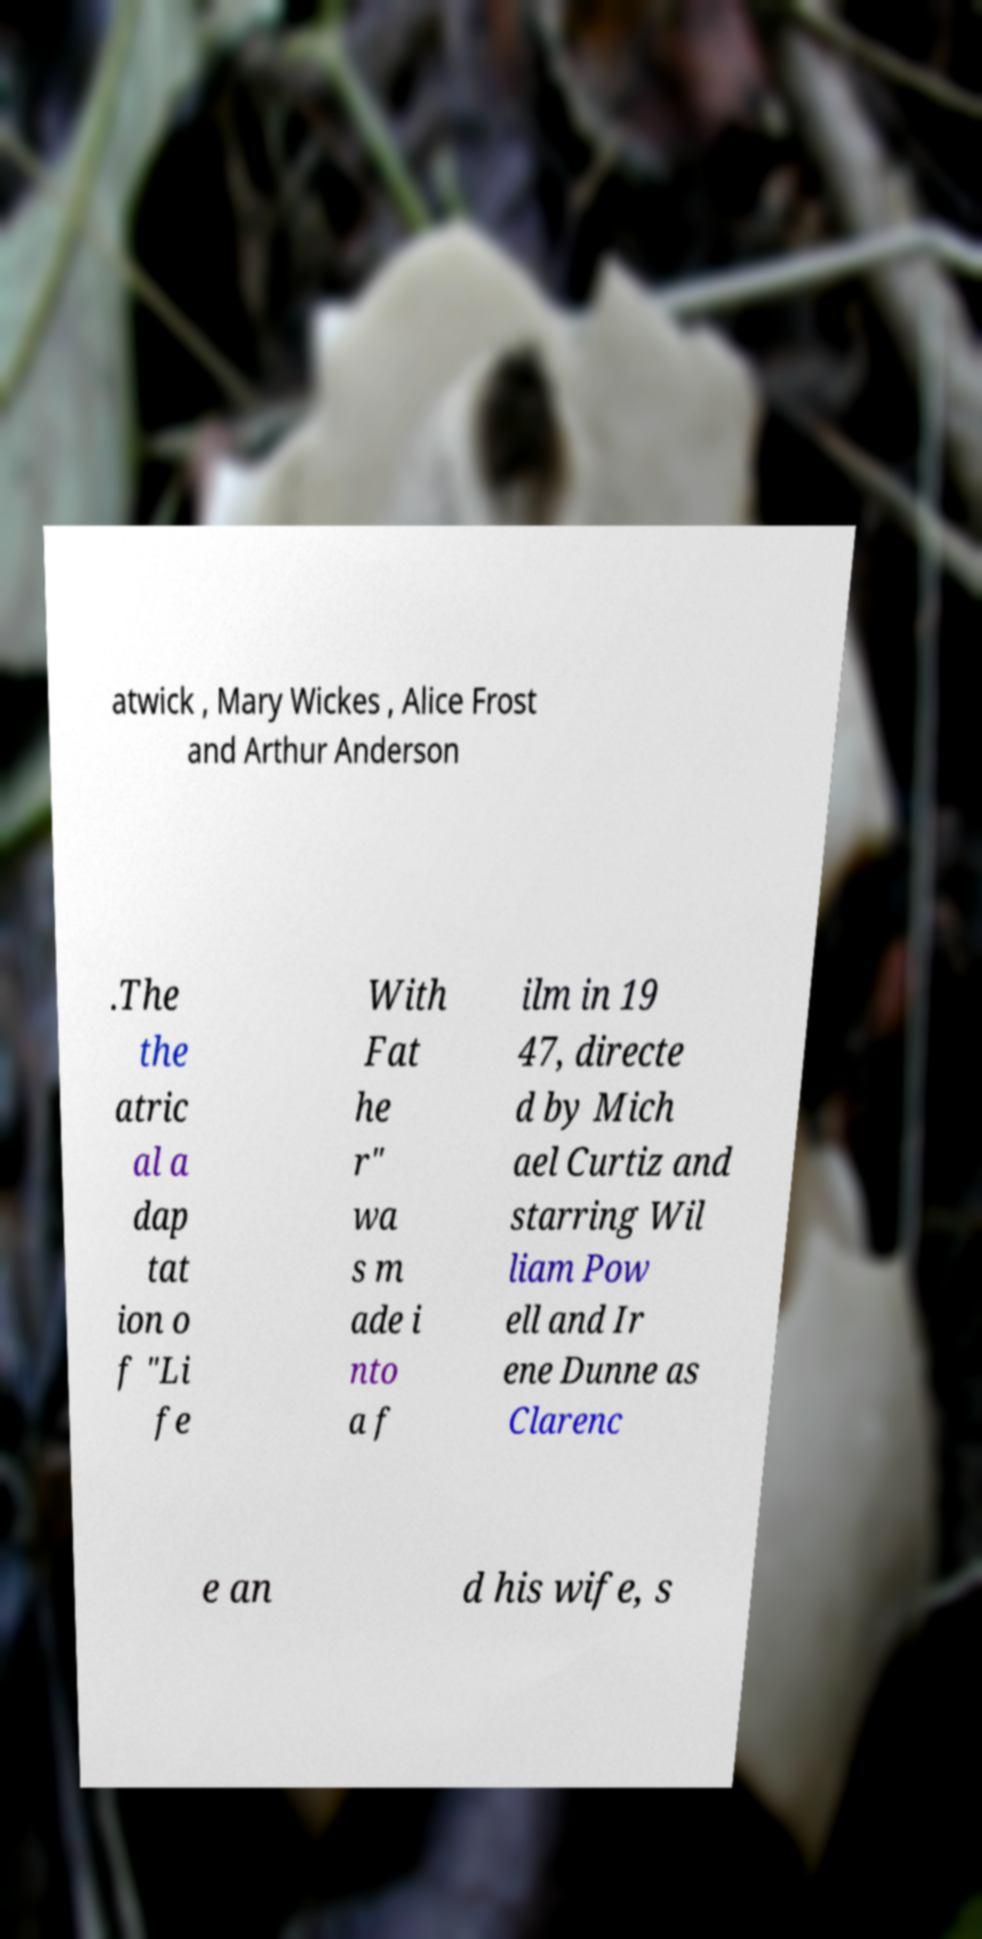For documentation purposes, I need the text within this image transcribed. Could you provide that? atwick , Mary Wickes , Alice Frost and Arthur Anderson .The the atric al a dap tat ion o f "Li fe With Fat he r" wa s m ade i nto a f ilm in 19 47, directe d by Mich ael Curtiz and starring Wil liam Pow ell and Ir ene Dunne as Clarenc e an d his wife, s 